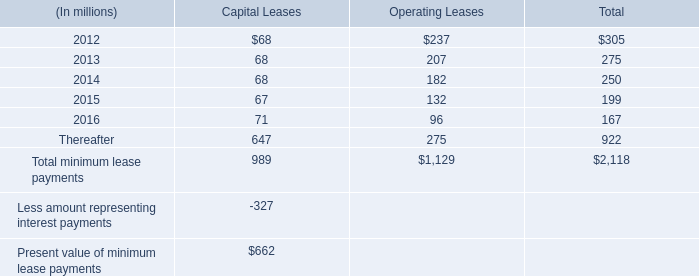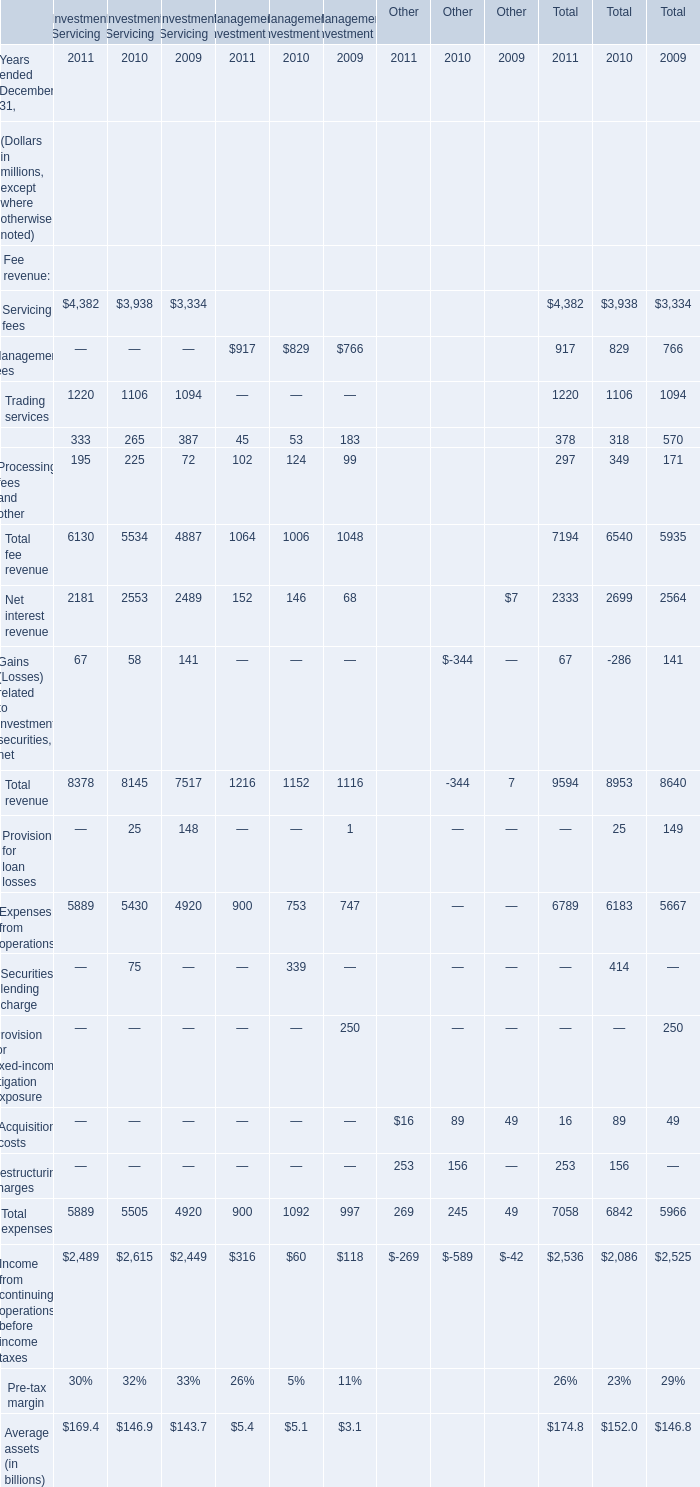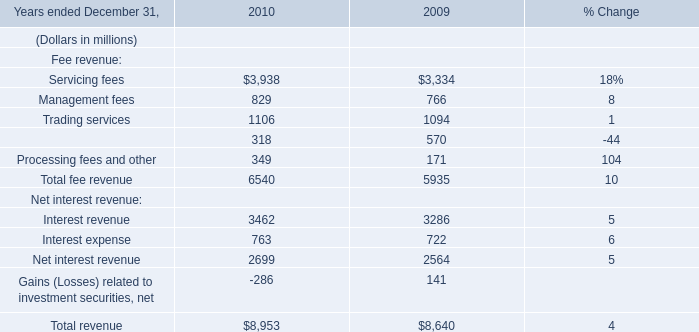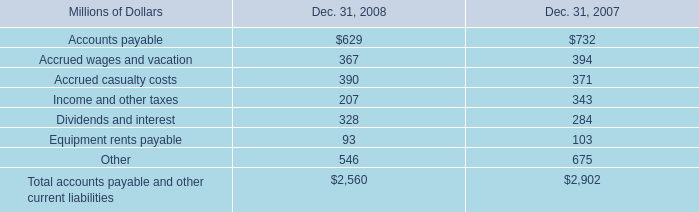What is the average value of Net interest revenue for Management Investment in 2011, 2010, and 2009? (in million) 
Computations: (((152 + 146) + 68) / 3)
Answer: 122.0. 